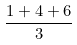<formula> <loc_0><loc_0><loc_500><loc_500>\frac { 1 + 4 + 6 } { 3 }</formula> 